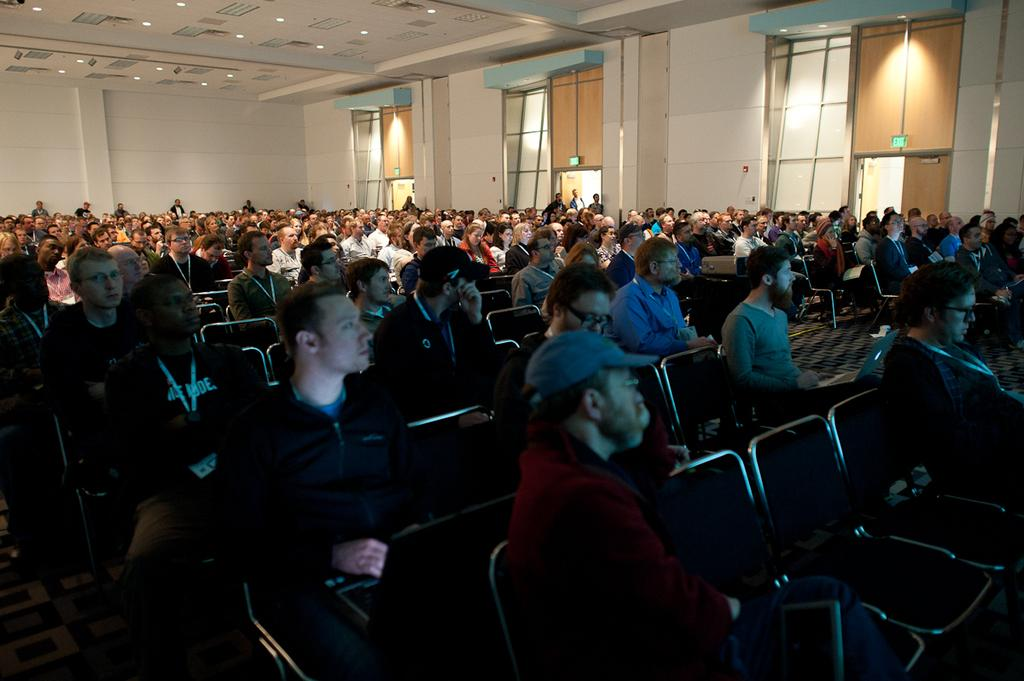What is the primary activity of the people in the image? The people in the image are sitting on chairs. What can be seen in the background of the image? There is a wall in the background of the image. What is located at the top of the image? There is a ceiling with lights at the top of the image. What type of plant can be seen growing on the coast in the image? There is no plant or coast present in the image; it features people sitting on chairs with a wall in the background and a ceiling with lights at the top. 